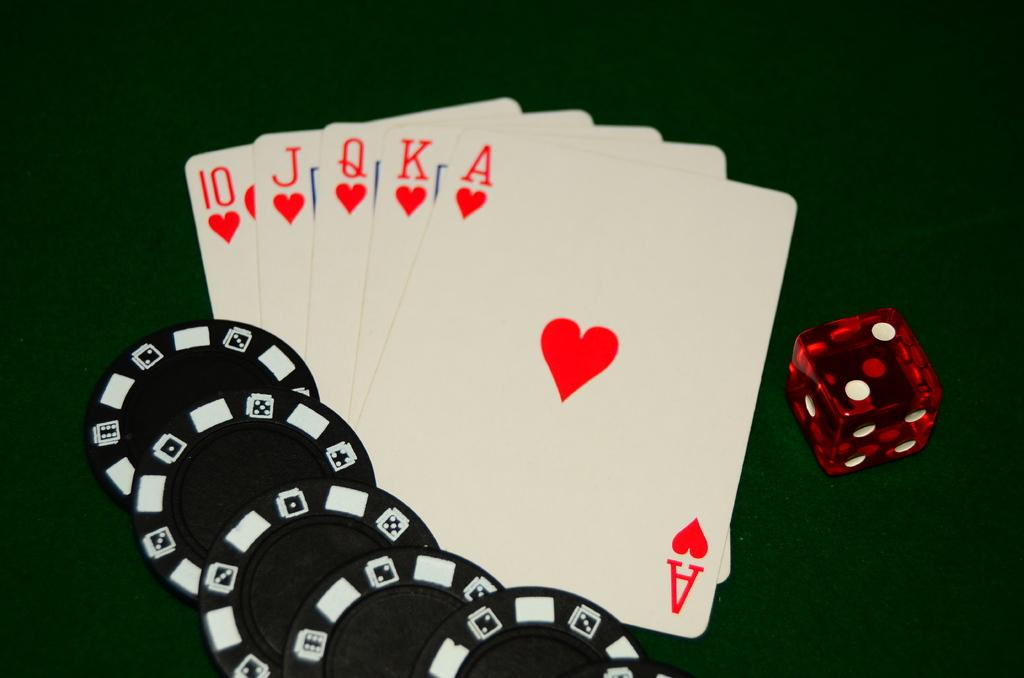<image>
Give a short and clear explanation of the subsequent image. Red hearts card with green backdrop and one red die and four black chips. 